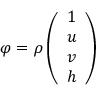<formula> <loc_0><loc_0><loc_500><loc_500>\varphi = \rho \left ( \begin{array} { l } { 1 } \\ { u } \\ { v } \\ { h } \end{array} \right )</formula> 